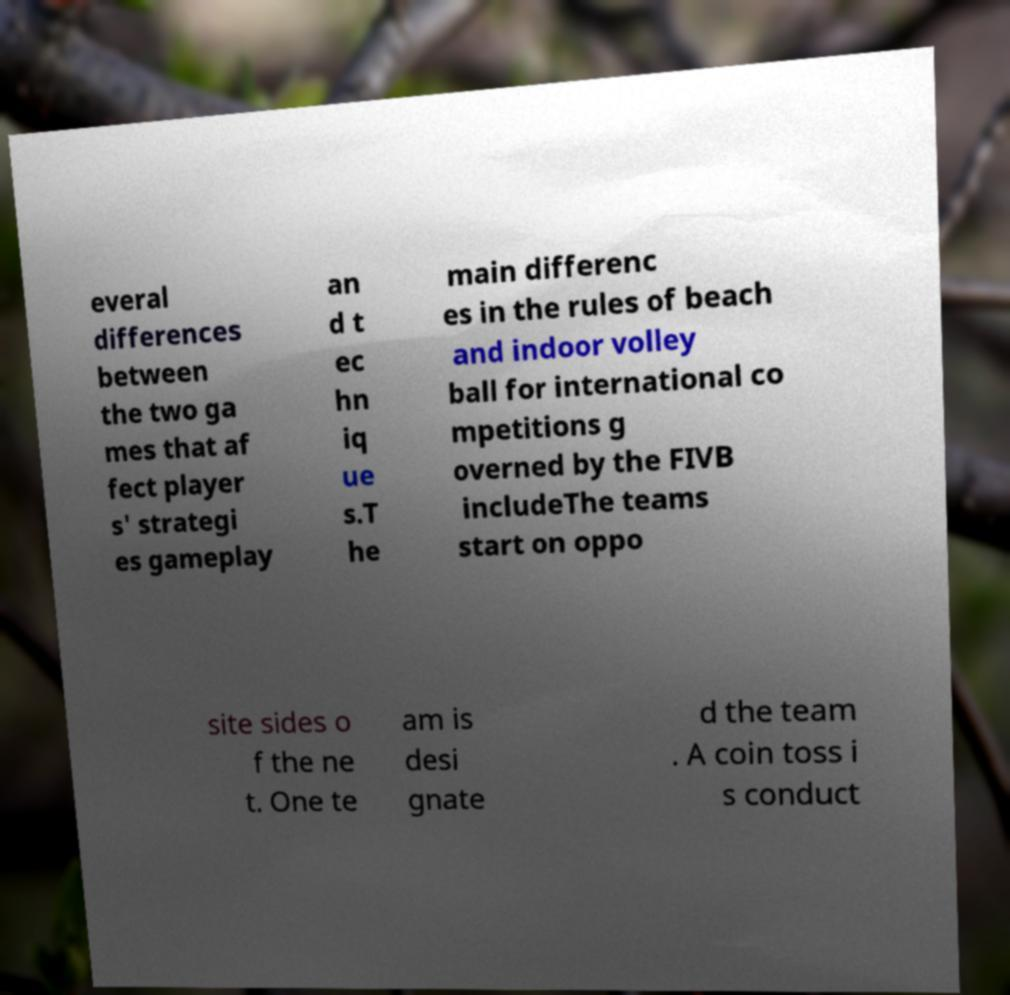For documentation purposes, I need the text within this image transcribed. Could you provide that? everal differences between the two ga mes that af fect player s' strategi es gameplay an d t ec hn iq ue s.T he main differenc es in the rules of beach and indoor volley ball for international co mpetitions g overned by the FIVB includeThe teams start on oppo site sides o f the ne t. One te am is desi gnate d the team . A coin toss i s conduct 